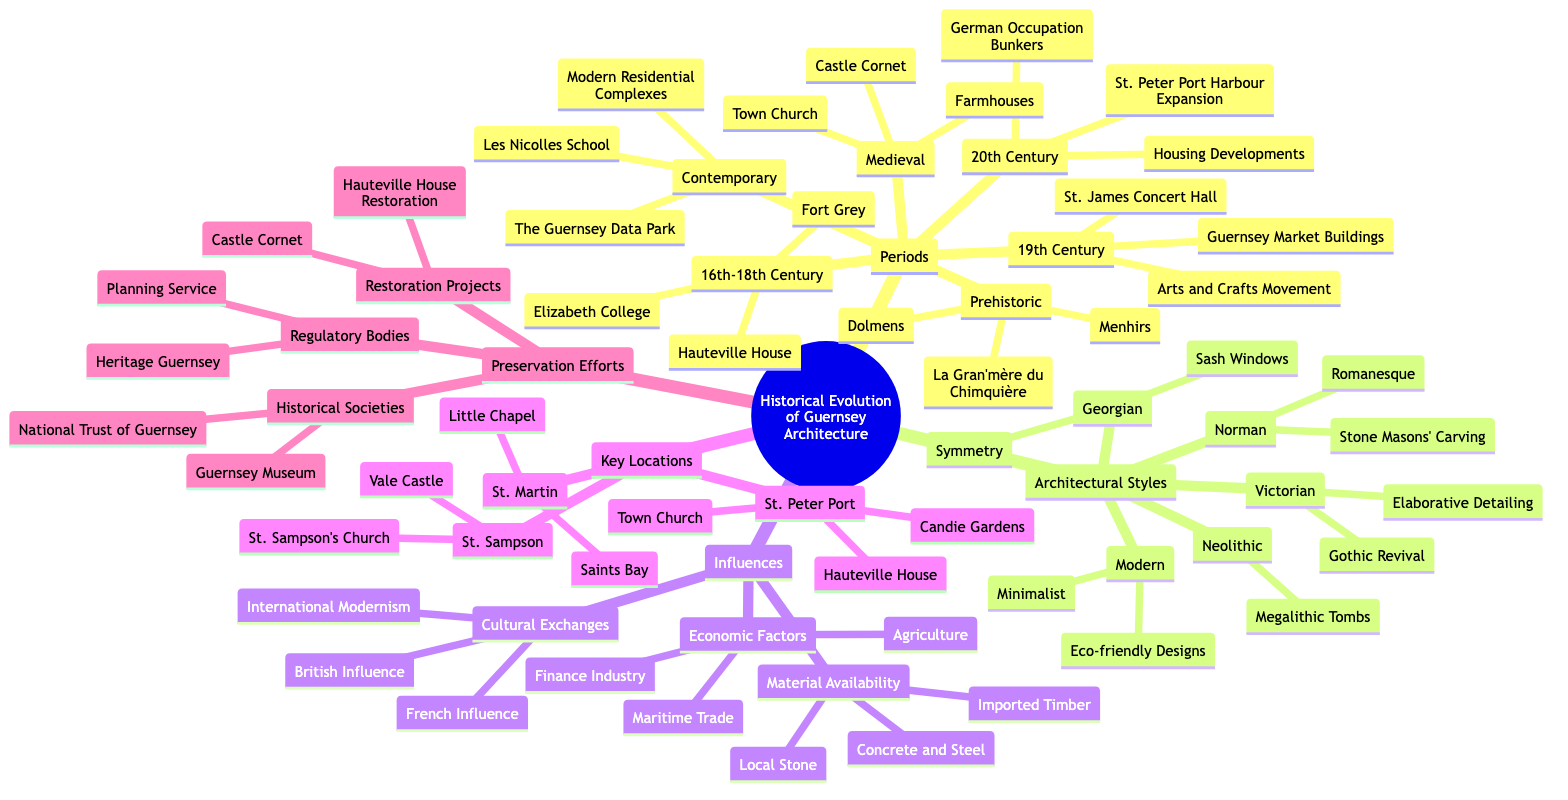What are the three periods listed under "Periods"? The "Periods" category lists six sub-nodes: Prehistoric, Medieval, 16th-18th Century, 19th Century, 20th Century, and Contemporary. Among these, three notable periods include Prehistoric, Medieval, and 16th-18th Century.
Answer: Prehistoric, Medieval, 16th-18th Century How many architectural styles are listed in the diagram? There are five distinct sub-nodes under "Architectural Styles": Neolithic, Norman, Georgian, Victorian, and Modern. Thus, the total count of architectural styles is five.
Answer: 5 Which architectural style is characterized by "Symmetry" and "Sash Windows"? The characteristics "Symmetry" and "Sash Windows" are found under the "Georgian" architectural style, indicating these design principles were typical of that era.
Answer: Georgian What are the key locations in St. Peter Port? In the "Key Locations" section, under "St. Peter Port," there are three notable sites: Town Church, Hauteville House, and Candie Gardens. These represent the key historical sites in that area.
Answer: Town Church, Hauteville House, Candie Gardens Which influence type includes "Maritime Trade"? Within the "Influences" section, "Maritime Trade" is listed under "Economic Factors," showcasing the economic influences on Guernsey architecture throughout history.
Answer: Economic Factors How many restoration projects are mentioned in the preservation efforts? The "Restoration Projects" node lists two specific projects: Castle Cornet and Hauteville House Restoration. Therefore, the total number of restoration projects mentioned is two.
Answer: 2 Which period includes "German Occupation Bunkers"? The "German Occupation Bunkers" are categorized under the "20th Century" period, indicating that these structures were built during that time in response to specific historical events.
Answer: 20th Century What is the main regulatory body listed in the preservation efforts? Under "Regulatory Bodies" in the "Preservation Efforts," the main regulatory body mentioned is "Heritage Guernsey," which plays a crucial role in preserving the architectural heritage of Guernsey.
Answer: Heritage Guernsey What are the influences listed under "Cultural Exchanges"? The "Cultural Exchanges" category features three influences: French Influence, British Influence, and International Modernism, revealing the cross-cultural effects on Guernsey architecture.
Answer: French Influence, British Influence, International Modernism 